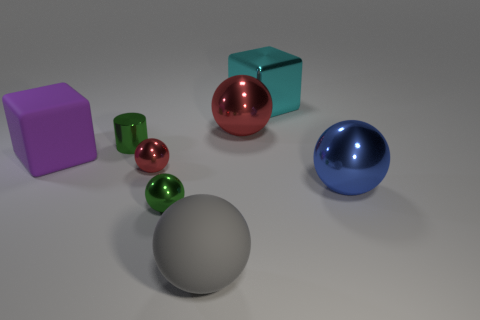What number of other things are there of the same size as the green metallic cylinder?
Make the answer very short. 2. There is a sphere that is the same color as the metal cylinder; what size is it?
Provide a succinct answer. Small. What number of metallic spheres are the same color as the small shiny cylinder?
Your answer should be very brief. 1. What shape is the purple thing?
Offer a very short reply. Cube. The object that is right of the matte cube and to the left of the tiny red sphere is what color?
Offer a terse response. Green. What is the big cyan cube made of?
Offer a terse response. Metal. What shape is the large object that is right of the cyan object?
Your response must be concise. Sphere. There is a matte sphere that is the same size as the blue metallic sphere; what is its color?
Make the answer very short. Gray. Is the big sphere that is behind the blue ball made of the same material as the small red thing?
Your response must be concise. Yes. There is a thing that is both in front of the blue object and to the left of the gray matte object; what is its size?
Ensure brevity in your answer.  Small. 